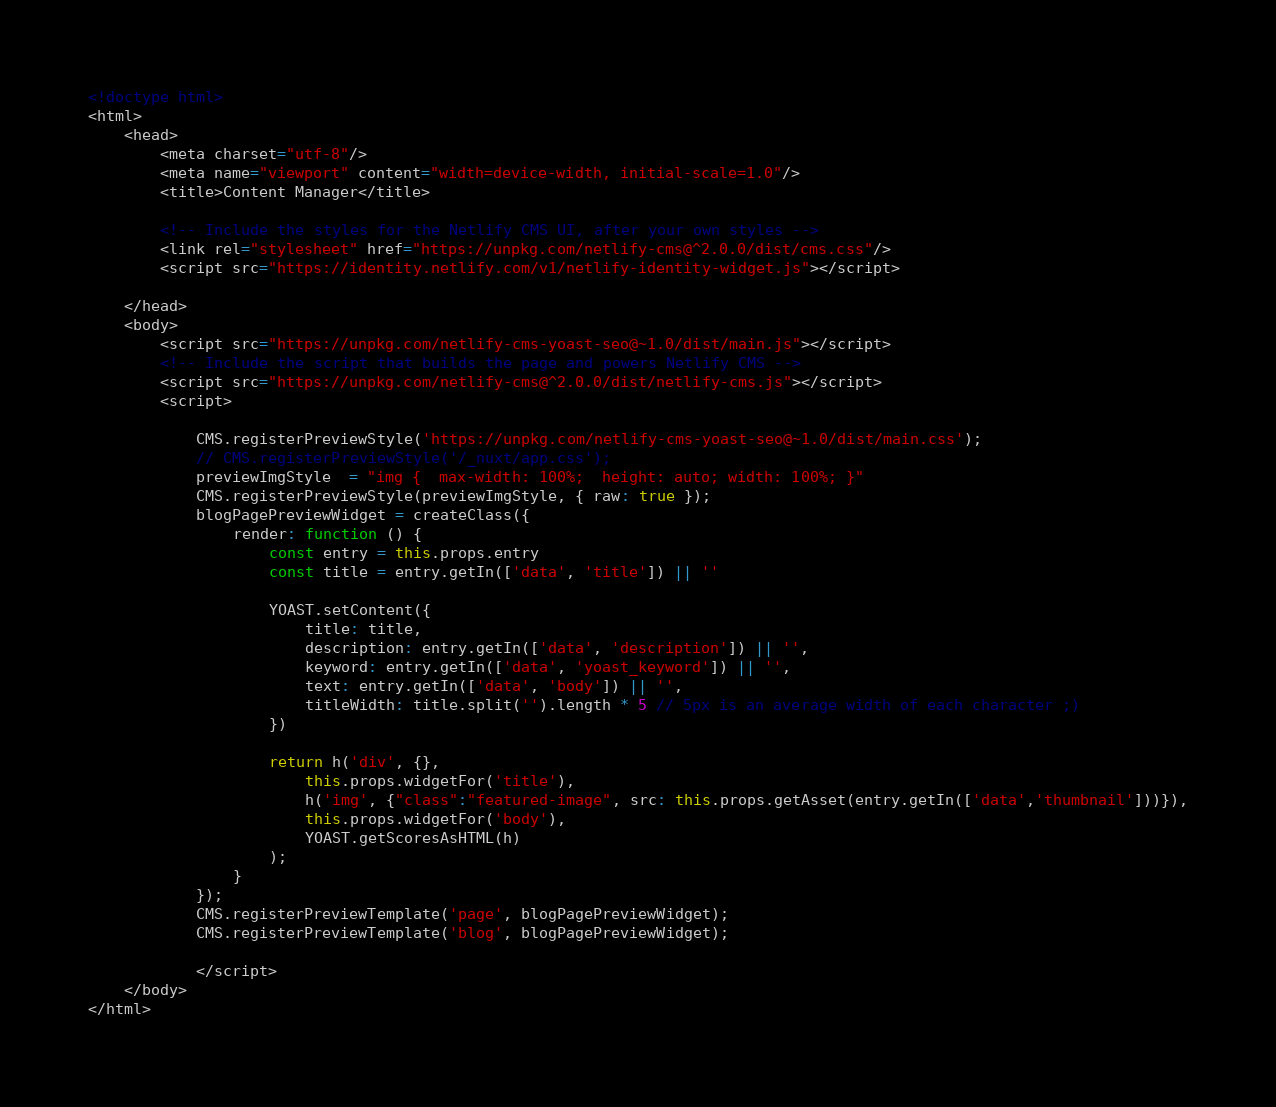Convert code to text. <code><loc_0><loc_0><loc_500><loc_500><_HTML_><!doctype html>
<html>
    <head>
        <meta charset="utf-8"/>
        <meta name="viewport" content="width=device-width, initial-scale=1.0"/>
        <title>Content Manager</title>

        <!-- Include the styles for the Netlify CMS UI, after your own styles -->
        <link rel="stylesheet" href="https://unpkg.com/netlify-cms@^2.0.0/dist/cms.css"/>
        <script src="https://identity.netlify.com/v1/netlify-identity-widget.js"></script>

    </head>
    <body>
        <script src="https://unpkg.com/netlify-cms-yoast-seo@~1.0/dist/main.js"></script>
        <!-- Include the script that builds the page and powers Netlify CMS -->
        <script src="https://unpkg.com/netlify-cms@^2.0.0/dist/netlify-cms.js"></script>
        <script>

            CMS.registerPreviewStyle('https://unpkg.com/netlify-cms-yoast-seo@~1.0/dist/main.css');
            // CMS.registerPreviewStyle('/_nuxt/app.css');
            previewImgStyle  = "img {  max-width: 100%;  height: auto; width: 100%; }"
            CMS.registerPreviewStyle(previewImgStyle, { raw: true });
            blogPagePreviewWidget = createClass({
                render: function () {
                    const entry = this.props.entry
                    const title = entry.getIn(['data', 'title']) || ''
        
                    YOAST.setContent({
                        title: title,
                        description: entry.getIn(['data', 'description']) || '',
                        keyword: entry.getIn(['data', 'yoast_keyword']) || '',
                        text: entry.getIn(['data', 'body']) || '',
                        titleWidth: title.split('').length * 5 // 5px is an average width of each character ;)
                    })
        
                    return h('div', {},
                        this.props.widgetFor('title'),
                        h('img', {"class":"featured-image", src: this.props.getAsset(entry.getIn(['data','thumbnail']))}),
                        this.props.widgetFor('body'),
                        YOAST.getScoresAsHTML(h)
                    );
                }
            });
            CMS.registerPreviewTemplate('page', blogPagePreviewWidget);
            CMS.registerPreviewTemplate('blog', blogPagePreviewWidget);
        
            </script>
    </body>
</html>
</code> 